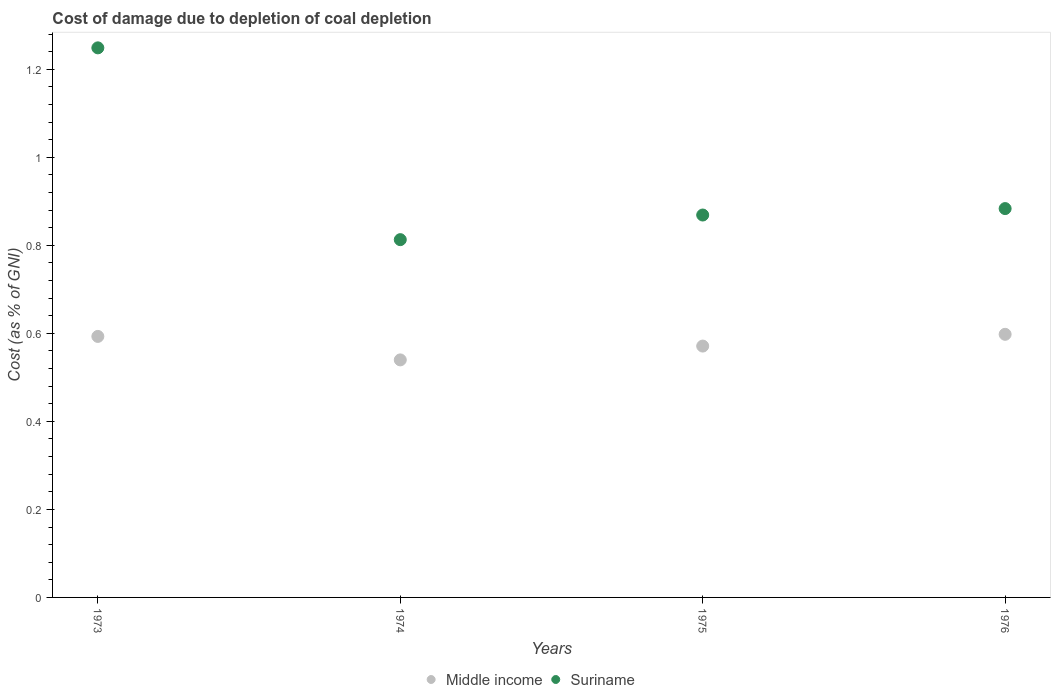How many different coloured dotlines are there?
Make the answer very short. 2. What is the cost of damage caused due to coal depletion in Suriname in 1973?
Provide a short and direct response. 1.25. Across all years, what is the maximum cost of damage caused due to coal depletion in Middle income?
Your response must be concise. 0.6. Across all years, what is the minimum cost of damage caused due to coal depletion in Suriname?
Your answer should be compact. 0.81. In which year was the cost of damage caused due to coal depletion in Middle income maximum?
Your response must be concise. 1976. In which year was the cost of damage caused due to coal depletion in Suriname minimum?
Your answer should be compact. 1974. What is the total cost of damage caused due to coal depletion in Suriname in the graph?
Your answer should be compact. 3.81. What is the difference between the cost of damage caused due to coal depletion in Suriname in 1975 and that in 1976?
Ensure brevity in your answer.  -0.01. What is the difference between the cost of damage caused due to coal depletion in Middle income in 1975 and the cost of damage caused due to coal depletion in Suriname in 1976?
Provide a short and direct response. -0.31. What is the average cost of damage caused due to coal depletion in Suriname per year?
Your answer should be very brief. 0.95. In the year 1973, what is the difference between the cost of damage caused due to coal depletion in Middle income and cost of damage caused due to coal depletion in Suriname?
Make the answer very short. -0.66. What is the ratio of the cost of damage caused due to coal depletion in Suriname in 1975 to that in 1976?
Your answer should be very brief. 0.98. Is the difference between the cost of damage caused due to coal depletion in Middle income in 1973 and 1974 greater than the difference between the cost of damage caused due to coal depletion in Suriname in 1973 and 1974?
Your answer should be very brief. No. What is the difference between the highest and the second highest cost of damage caused due to coal depletion in Suriname?
Your answer should be very brief. 0.37. What is the difference between the highest and the lowest cost of damage caused due to coal depletion in Suriname?
Give a very brief answer. 0.44. Is the sum of the cost of damage caused due to coal depletion in Middle income in 1974 and 1976 greater than the maximum cost of damage caused due to coal depletion in Suriname across all years?
Provide a succinct answer. No. Is the cost of damage caused due to coal depletion in Suriname strictly greater than the cost of damage caused due to coal depletion in Middle income over the years?
Your answer should be compact. Yes. How many dotlines are there?
Ensure brevity in your answer.  2. How many years are there in the graph?
Offer a terse response. 4. What is the difference between two consecutive major ticks on the Y-axis?
Offer a terse response. 0.2. Does the graph contain grids?
Provide a succinct answer. No. Where does the legend appear in the graph?
Keep it short and to the point. Bottom center. How are the legend labels stacked?
Offer a terse response. Horizontal. What is the title of the graph?
Offer a terse response. Cost of damage due to depletion of coal depletion. Does "Brazil" appear as one of the legend labels in the graph?
Keep it short and to the point. No. What is the label or title of the Y-axis?
Your answer should be compact. Cost (as % of GNI). What is the Cost (as % of GNI) in Middle income in 1973?
Your answer should be very brief. 0.59. What is the Cost (as % of GNI) of Suriname in 1973?
Provide a short and direct response. 1.25. What is the Cost (as % of GNI) in Middle income in 1974?
Ensure brevity in your answer.  0.54. What is the Cost (as % of GNI) of Suriname in 1974?
Provide a succinct answer. 0.81. What is the Cost (as % of GNI) of Middle income in 1975?
Your answer should be very brief. 0.57. What is the Cost (as % of GNI) of Suriname in 1975?
Provide a short and direct response. 0.87. What is the Cost (as % of GNI) in Middle income in 1976?
Make the answer very short. 0.6. What is the Cost (as % of GNI) in Suriname in 1976?
Offer a very short reply. 0.88. Across all years, what is the maximum Cost (as % of GNI) of Middle income?
Keep it short and to the point. 0.6. Across all years, what is the maximum Cost (as % of GNI) of Suriname?
Provide a short and direct response. 1.25. Across all years, what is the minimum Cost (as % of GNI) in Middle income?
Your answer should be very brief. 0.54. Across all years, what is the minimum Cost (as % of GNI) of Suriname?
Provide a short and direct response. 0.81. What is the total Cost (as % of GNI) in Middle income in the graph?
Offer a very short reply. 2.3. What is the total Cost (as % of GNI) of Suriname in the graph?
Keep it short and to the point. 3.81. What is the difference between the Cost (as % of GNI) in Middle income in 1973 and that in 1974?
Your answer should be very brief. 0.05. What is the difference between the Cost (as % of GNI) in Suriname in 1973 and that in 1974?
Give a very brief answer. 0.44. What is the difference between the Cost (as % of GNI) of Middle income in 1973 and that in 1975?
Keep it short and to the point. 0.02. What is the difference between the Cost (as % of GNI) in Suriname in 1973 and that in 1975?
Your answer should be compact. 0.38. What is the difference between the Cost (as % of GNI) of Middle income in 1973 and that in 1976?
Give a very brief answer. -0. What is the difference between the Cost (as % of GNI) of Suriname in 1973 and that in 1976?
Provide a succinct answer. 0.37. What is the difference between the Cost (as % of GNI) of Middle income in 1974 and that in 1975?
Offer a terse response. -0.03. What is the difference between the Cost (as % of GNI) in Suriname in 1974 and that in 1975?
Provide a succinct answer. -0.06. What is the difference between the Cost (as % of GNI) of Middle income in 1974 and that in 1976?
Offer a terse response. -0.06. What is the difference between the Cost (as % of GNI) in Suriname in 1974 and that in 1976?
Make the answer very short. -0.07. What is the difference between the Cost (as % of GNI) in Middle income in 1975 and that in 1976?
Offer a very short reply. -0.03. What is the difference between the Cost (as % of GNI) in Suriname in 1975 and that in 1976?
Ensure brevity in your answer.  -0.01. What is the difference between the Cost (as % of GNI) in Middle income in 1973 and the Cost (as % of GNI) in Suriname in 1974?
Ensure brevity in your answer.  -0.22. What is the difference between the Cost (as % of GNI) of Middle income in 1973 and the Cost (as % of GNI) of Suriname in 1975?
Your answer should be compact. -0.28. What is the difference between the Cost (as % of GNI) of Middle income in 1973 and the Cost (as % of GNI) of Suriname in 1976?
Give a very brief answer. -0.29. What is the difference between the Cost (as % of GNI) in Middle income in 1974 and the Cost (as % of GNI) in Suriname in 1975?
Offer a very short reply. -0.33. What is the difference between the Cost (as % of GNI) in Middle income in 1974 and the Cost (as % of GNI) in Suriname in 1976?
Offer a very short reply. -0.34. What is the difference between the Cost (as % of GNI) of Middle income in 1975 and the Cost (as % of GNI) of Suriname in 1976?
Make the answer very short. -0.31. What is the average Cost (as % of GNI) of Middle income per year?
Offer a terse response. 0.58. What is the average Cost (as % of GNI) of Suriname per year?
Provide a short and direct response. 0.95. In the year 1973, what is the difference between the Cost (as % of GNI) in Middle income and Cost (as % of GNI) in Suriname?
Provide a short and direct response. -0.66. In the year 1974, what is the difference between the Cost (as % of GNI) of Middle income and Cost (as % of GNI) of Suriname?
Your answer should be compact. -0.27. In the year 1975, what is the difference between the Cost (as % of GNI) of Middle income and Cost (as % of GNI) of Suriname?
Provide a succinct answer. -0.3. In the year 1976, what is the difference between the Cost (as % of GNI) of Middle income and Cost (as % of GNI) of Suriname?
Give a very brief answer. -0.29. What is the ratio of the Cost (as % of GNI) in Middle income in 1973 to that in 1974?
Make the answer very short. 1.1. What is the ratio of the Cost (as % of GNI) in Suriname in 1973 to that in 1974?
Keep it short and to the point. 1.54. What is the ratio of the Cost (as % of GNI) of Middle income in 1973 to that in 1975?
Provide a short and direct response. 1.04. What is the ratio of the Cost (as % of GNI) of Suriname in 1973 to that in 1975?
Your answer should be compact. 1.44. What is the ratio of the Cost (as % of GNI) in Suriname in 1973 to that in 1976?
Offer a very short reply. 1.41. What is the ratio of the Cost (as % of GNI) in Middle income in 1974 to that in 1975?
Provide a short and direct response. 0.94. What is the ratio of the Cost (as % of GNI) of Suriname in 1974 to that in 1975?
Offer a very short reply. 0.94. What is the ratio of the Cost (as % of GNI) of Middle income in 1974 to that in 1976?
Provide a short and direct response. 0.9. What is the ratio of the Cost (as % of GNI) in Suriname in 1974 to that in 1976?
Provide a succinct answer. 0.92. What is the ratio of the Cost (as % of GNI) in Middle income in 1975 to that in 1976?
Offer a terse response. 0.96. What is the ratio of the Cost (as % of GNI) in Suriname in 1975 to that in 1976?
Your answer should be very brief. 0.98. What is the difference between the highest and the second highest Cost (as % of GNI) of Middle income?
Your answer should be compact. 0. What is the difference between the highest and the second highest Cost (as % of GNI) of Suriname?
Keep it short and to the point. 0.37. What is the difference between the highest and the lowest Cost (as % of GNI) of Middle income?
Offer a terse response. 0.06. What is the difference between the highest and the lowest Cost (as % of GNI) of Suriname?
Your answer should be compact. 0.44. 